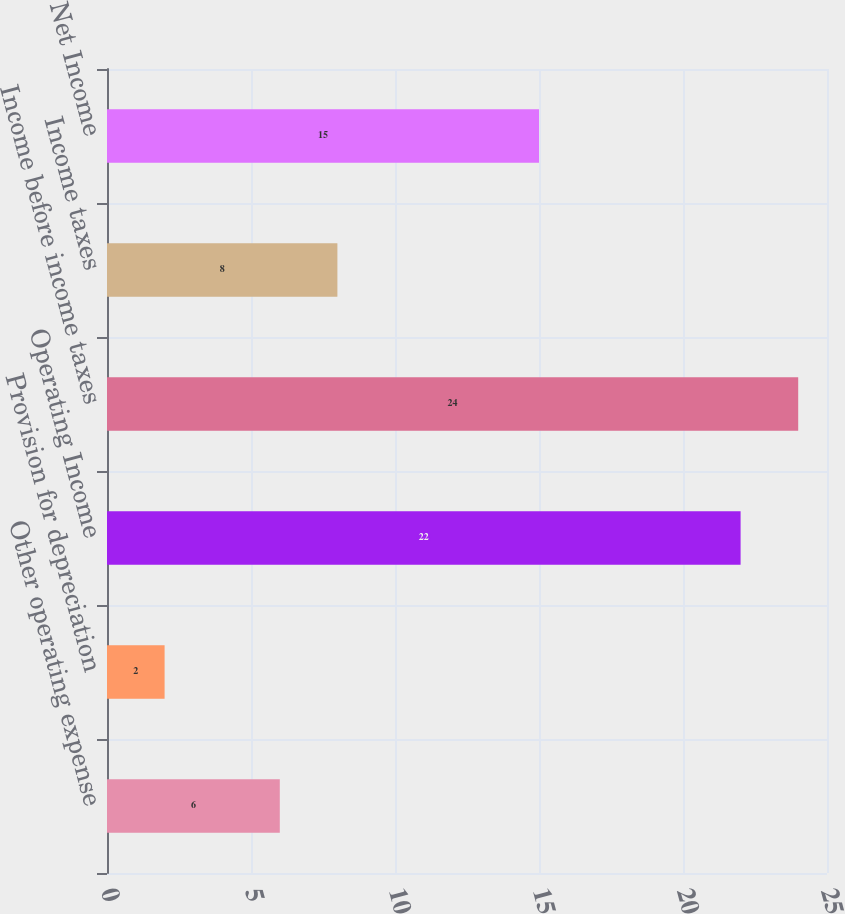Convert chart to OTSL. <chart><loc_0><loc_0><loc_500><loc_500><bar_chart><fcel>Other operating expense<fcel>Provision for depreciation<fcel>Operating Income<fcel>Income before income taxes<fcel>Income taxes<fcel>Net Income<nl><fcel>6<fcel>2<fcel>22<fcel>24<fcel>8<fcel>15<nl></chart> 